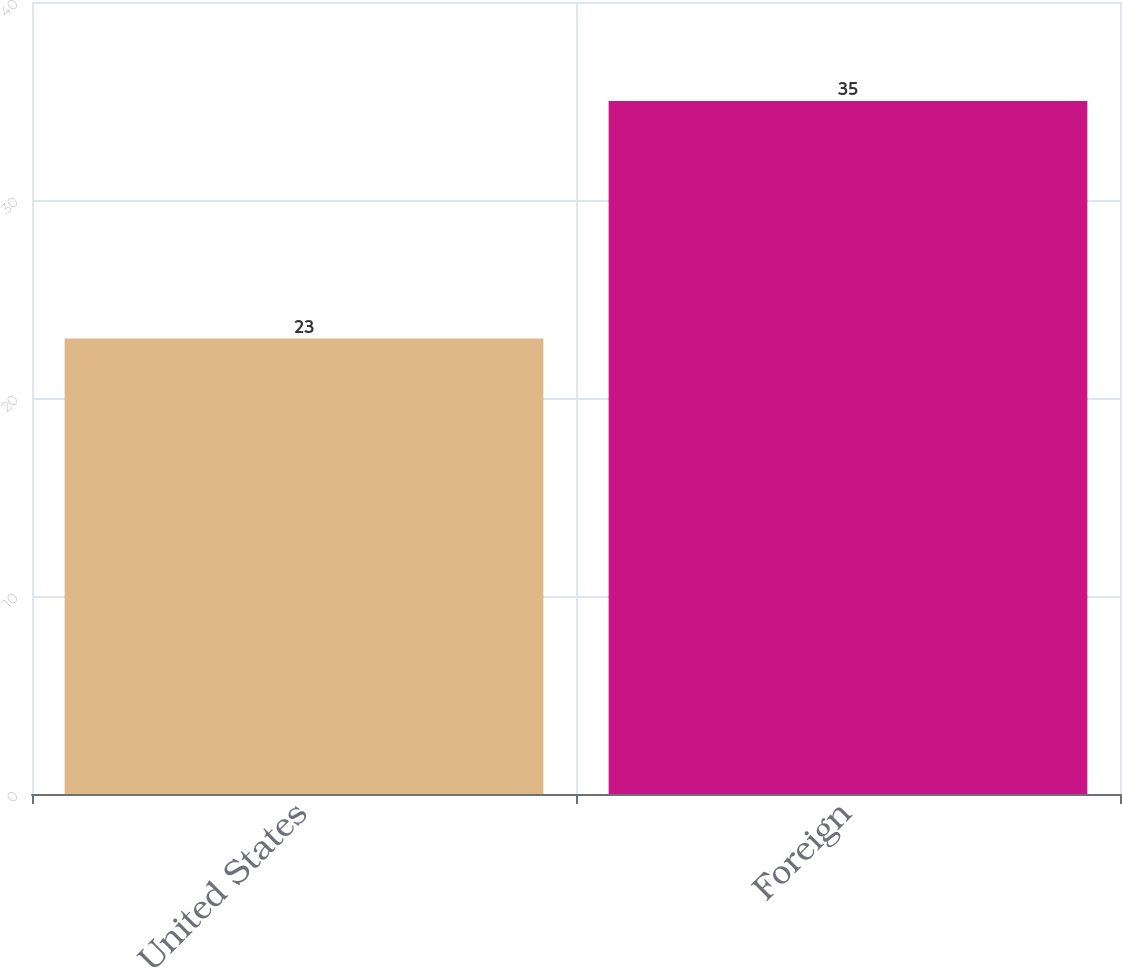<chart> <loc_0><loc_0><loc_500><loc_500><bar_chart><fcel>United States<fcel>Foreign<nl><fcel>23<fcel>35<nl></chart> 